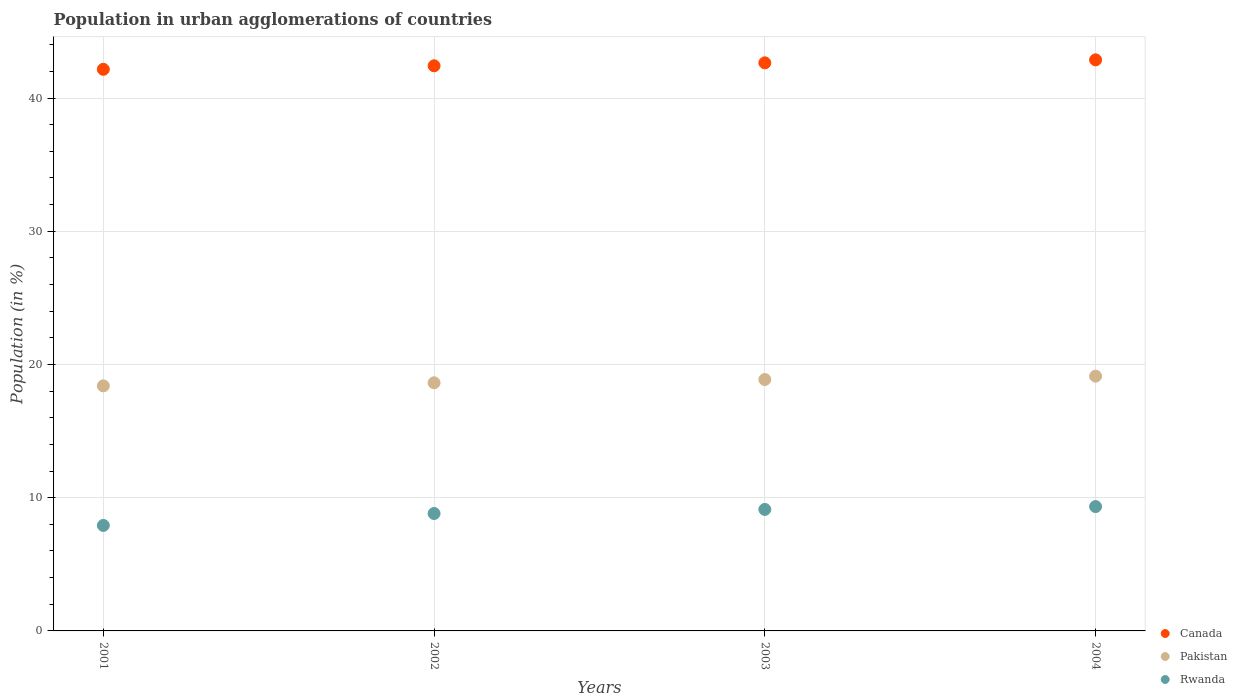How many different coloured dotlines are there?
Give a very brief answer. 3. What is the percentage of population in urban agglomerations in Canada in 2003?
Provide a succinct answer. 42.64. Across all years, what is the maximum percentage of population in urban agglomerations in Pakistan?
Offer a terse response. 19.12. Across all years, what is the minimum percentage of population in urban agglomerations in Rwanda?
Your answer should be compact. 7.92. What is the total percentage of population in urban agglomerations in Rwanda in the graph?
Your response must be concise. 35.19. What is the difference between the percentage of population in urban agglomerations in Rwanda in 2001 and that in 2004?
Offer a terse response. -1.41. What is the difference between the percentage of population in urban agglomerations in Pakistan in 2004 and the percentage of population in urban agglomerations in Canada in 2003?
Provide a succinct answer. -23.52. What is the average percentage of population in urban agglomerations in Rwanda per year?
Your answer should be compact. 8.8. In the year 2003, what is the difference between the percentage of population in urban agglomerations in Canada and percentage of population in urban agglomerations in Pakistan?
Your answer should be very brief. 23.77. In how many years, is the percentage of population in urban agglomerations in Canada greater than 30 %?
Give a very brief answer. 4. What is the ratio of the percentage of population in urban agglomerations in Pakistan in 2001 to that in 2004?
Keep it short and to the point. 0.96. Is the percentage of population in urban agglomerations in Rwanda in 2003 less than that in 2004?
Your response must be concise. Yes. What is the difference between the highest and the second highest percentage of population in urban agglomerations in Rwanda?
Offer a very short reply. 0.21. What is the difference between the highest and the lowest percentage of population in urban agglomerations in Pakistan?
Provide a short and direct response. 0.73. Is it the case that in every year, the sum of the percentage of population in urban agglomerations in Rwanda and percentage of population in urban agglomerations in Pakistan  is greater than the percentage of population in urban agglomerations in Canada?
Keep it short and to the point. No. Does the percentage of population in urban agglomerations in Pakistan monotonically increase over the years?
Offer a terse response. Yes. Is the percentage of population in urban agglomerations in Canada strictly greater than the percentage of population in urban agglomerations in Pakistan over the years?
Keep it short and to the point. Yes. How many dotlines are there?
Offer a very short reply. 3. How many years are there in the graph?
Your answer should be very brief. 4. Does the graph contain any zero values?
Your answer should be very brief. No. Where does the legend appear in the graph?
Your answer should be compact. Bottom right. How are the legend labels stacked?
Make the answer very short. Vertical. What is the title of the graph?
Offer a very short reply. Population in urban agglomerations of countries. Does "Palau" appear as one of the legend labels in the graph?
Your response must be concise. No. What is the label or title of the X-axis?
Offer a terse response. Years. What is the Population (in %) of Canada in 2001?
Your answer should be very brief. 42.16. What is the Population (in %) in Pakistan in 2001?
Make the answer very short. 18.4. What is the Population (in %) in Rwanda in 2001?
Your answer should be very brief. 7.92. What is the Population (in %) in Canada in 2002?
Ensure brevity in your answer.  42.42. What is the Population (in %) in Pakistan in 2002?
Provide a succinct answer. 18.63. What is the Population (in %) of Rwanda in 2002?
Give a very brief answer. 8.81. What is the Population (in %) of Canada in 2003?
Keep it short and to the point. 42.64. What is the Population (in %) of Pakistan in 2003?
Offer a very short reply. 18.87. What is the Population (in %) in Rwanda in 2003?
Give a very brief answer. 9.12. What is the Population (in %) in Canada in 2004?
Your answer should be compact. 42.87. What is the Population (in %) in Pakistan in 2004?
Keep it short and to the point. 19.12. What is the Population (in %) in Rwanda in 2004?
Keep it short and to the point. 9.33. Across all years, what is the maximum Population (in %) in Canada?
Provide a short and direct response. 42.87. Across all years, what is the maximum Population (in %) of Pakistan?
Offer a terse response. 19.12. Across all years, what is the maximum Population (in %) of Rwanda?
Make the answer very short. 9.33. Across all years, what is the minimum Population (in %) of Canada?
Your answer should be compact. 42.16. Across all years, what is the minimum Population (in %) in Pakistan?
Provide a succinct answer. 18.4. Across all years, what is the minimum Population (in %) of Rwanda?
Offer a very short reply. 7.92. What is the total Population (in %) of Canada in the graph?
Ensure brevity in your answer.  170.09. What is the total Population (in %) of Pakistan in the graph?
Make the answer very short. 75.02. What is the total Population (in %) in Rwanda in the graph?
Provide a succinct answer. 35.19. What is the difference between the Population (in %) of Canada in 2001 and that in 2002?
Ensure brevity in your answer.  -0.26. What is the difference between the Population (in %) in Pakistan in 2001 and that in 2002?
Provide a short and direct response. -0.23. What is the difference between the Population (in %) of Rwanda in 2001 and that in 2002?
Give a very brief answer. -0.9. What is the difference between the Population (in %) in Canada in 2001 and that in 2003?
Provide a succinct answer. -0.49. What is the difference between the Population (in %) in Pakistan in 2001 and that in 2003?
Give a very brief answer. -0.48. What is the difference between the Population (in %) of Rwanda in 2001 and that in 2003?
Offer a terse response. -1.2. What is the difference between the Population (in %) in Canada in 2001 and that in 2004?
Offer a terse response. -0.71. What is the difference between the Population (in %) in Pakistan in 2001 and that in 2004?
Your answer should be compact. -0.73. What is the difference between the Population (in %) of Rwanda in 2001 and that in 2004?
Ensure brevity in your answer.  -1.41. What is the difference between the Population (in %) of Canada in 2002 and that in 2003?
Offer a terse response. -0.22. What is the difference between the Population (in %) of Pakistan in 2002 and that in 2003?
Your answer should be compact. -0.25. What is the difference between the Population (in %) of Rwanda in 2002 and that in 2003?
Make the answer very short. -0.3. What is the difference between the Population (in %) in Canada in 2002 and that in 2004?
Your response must be concise. -0.45. What is the difference between the Population (in %) in Pakistan in 2002 and that in 2004?
Your response must be concise. -0.5. What is the difference between the Population (in %) of Rwanda in 2002 and that in 2004?
Your answer should be compact. -0.52. What is the difference between the Population (in %) in Canada in 2003 and that in 2004?
Your answer should be compact. -0.22. What is the difference between the Population (in %) of Pakistan in 2003 and that in 2004?
Offer a terse response. -0.25. What is the difference between the Population (in %) of Rwanda in 2003 and that in 2004?
Offer a very short reply. -0.21. What is the difference between the Population (in %) in Canada in 2001 and the Population (in %) in Pakistan in 2002?
Offer a terse response. 23.53. What is the difference between the Population (in %) of Canada in 2001 and the Population (in %) of Rwanda in 2002?
Your response must be concise. 33.34. What is the difference between the Population (in %) of Pakistan in 2001 and the Population (in %) of Rwanda in 2002?
Keep it short and to the point. 9.58. What is the difference between the Population (in %) in Canada in 2001 and the Population (in %) in Pakistan in 2003?
Ensure brevity in your answer.  23.29. What is the difference between the Population (in %) of Canada in 2001 and the Population (in %) of Rwanda in 2003?
Keep it short and to the point. 33.04. What is the difference between the Population (in %) in Pakistan in 2001 and the Population (in %) in Rwanda in 2003?
Provide a short and direct response. 9.28. What is the difference between the Population (in %) of Canada in 2001 and the Population (in %) of Pakistan in 2004?
Provide a short and direct response. 23.03. What is the difference between the Population (in %) of Canada in 2001 and the Population (in %) of Rwanda in 2004?
Offer a very short reply. 32.82. What is the difference between the Population (in %) in Pakistan in 2001 and the Population (in %) in Rwanda in 2004?
Your response must be concise. 9.06. What is the difference between the Population (in %) of Canada in 2002 and the Population (in %) of Pakistan in 2003?
Keep it short and to the point. 23.55. What is the difference between the Population (in %) in Canada in 2002 and the Population (in %) in Rwanda in 2003?
Offer a very short reply. 33.3. What is the difference between the Population (in %) of Pakistan in 2002 and the Population (in %) of Rwanda in 2003?
Your answer should be very brief. 9.51. What is the difference between the Population (in %) in Canada in 2002 and the Population (in %) in Pakistan in 2004?
Give a very brief answer. 23.3. What is the difference between the Population (in %) of Canada in 2002 and the Population (in %) of Rwanda in 2004?
Your answer should be very brief. 33.09. What is the difference between the Population (in %) in Pakistan in 2002 and the Population (in %) in Rwanda in 2004?
Your answer should be very brief. 9.29. What is the difference between the Population (in %) in Canada in 2003 and the Population (in %) in Pakistan in 2004?
Your response must be concise. 23.52. What is the difference between the Population (in %) of Canada in 2003 and the Population (in %) of Rwanda in 2004?
Give a very brief answer. 33.31. What is the difference between the Population (in %) of Pakistan in 2003 and the Population (in %) of Rwanda in 2004?
Offer a very short reply. 9.54. What is the average Population (in %) in Canada per year?
Provide a succinct answer. 42.52. What is the average Population (in %) in Pakistan per year?
Your answer should be compact. 18.75. What is the average Population (in %) of Rwanda per year?
Your answer should be compact. 8.8. In the year 2001, what is the difference between the Population (in %) of Canada and Population (in %) of Pakistan?
Ensure brevity in your answer.  23.76. In the year 2001, what is the difference between the Population (in %) of Canada and Population (in %) of Rwanda?
Your answer should be very brief. 34.24. In the year 2001, what is the difference between the Population (in %) in Pakistan and Population (in %) in Rwanda?
Make the answer very short. 10.48. In the year 2002, what is the difference between the Population (in %) of Canada and Population (in %) of Pakistan?
Keep it short and to the point. 23.79. In the year 2002, what is the difference between the Population (in %) in Canada and Population (in %) in Rwanda?
Ensure brevity in your answer.  33.61. In the year 2002, what is the difference between the Population (in %) in Pakistan and Population (in %) in Rwanda?
Your answer should be very brief. 9.81. In the year 2003, what is the difference between the Population (in %) in Canada and Population (in %) in Pakistan?
Offer a terse response. 23.77. In the year 2003, what is the difference between the Population (in %) of Canada and Population (in %) of Rwanda?
Offer a terse response. 33.52. In the year 2003, what is the difference between the Population (in %) in Pakistan and Population (in %) in Rwanda?
Provide a succinct answer. 9.75. In the year 2004, what is the difference between the Population (in %) of Canada and Population (in %) of Pakistan?
Ensure brevity in your answer.  23.74. In the year 2004, what is the difference between the Population (in %) in Canada and Population (in %) in Rwanda?
Offer a very short reply. 33.53. In the year 2004, what is the difference between the Population (in %) of Pakistan and Population (in %) of Rwanda?
Your answer should be very brief. 9.79. What is the ratio of the Population (in %) in Pakistan in 2001 to that in 2002?
Offer a very short reply. 0.99. What is the ratio of the Population (in %) of Rwanda in 2001 to that in 2002?
Offer a terse response. 0.9. What is the ratio of the Population (in %) of Canada in 2001 to that in 2003?
Ensure brevity in your answer.  0.99. What is the ratio of the Population (in %) of Pakistan in 2001 to that in 2003?
Your response must be concise. 0.97. What is the ratio of the Population (in %) of Rwanda in 2001 to that in 2003?
Keep it short and to the point. 0.87. What is the ratio of the Population (in %) in Canada in 2001 to that in 2004?
Your answer should be very brief. 0.98. What is the ratio of the Population (in %) in Pakistan in 2001 to that in 2004?
Offer a very short reply. 0.96. What is the ratio of the Population (in %) of Rwanda in 2001 to that in 2004?
Your answer should be compact. 0.85. What is the ratio of the Population (in %) of Rwanda in 2002 to that in 2003?
Your response must be concise. 0.97. What is the ratio of the Population (in %) in Canada in 2002 to that in 2004?
Your answer should be compact. 0.99. What is the ratio of the Population (in %) in Rwanda in 2002 to that in 2004?
Keep it short and to the point. 0.94. What is the ratio of the Population (in %) in Rwanda in 2003 to that in 2004?
Your response must be concise. 0.98. What is the difference between the highest and the second highest Population (in %) of Canada?
Give a very brief answer. 0.22. What is the difference between the highest and the second highest Population (in %) of Pakistan?
Keep it short and to the point. 0.25. What is the difference between the highest and the second highest Population (in %) in Rwanda?
Ensure brevity in your answer.  0.21. What is the difference between the highest and the lowest Population (in %) of Canada?
Your response must be concise. 0.71. What is the difference between the highest and the lowest Population (in %) in Pakistan?
Provide a succinct answer. 0.73. What is the difference between the highest and the lowest Population (in %) of Rwanda?
Give a very brief answer. 1.41. 